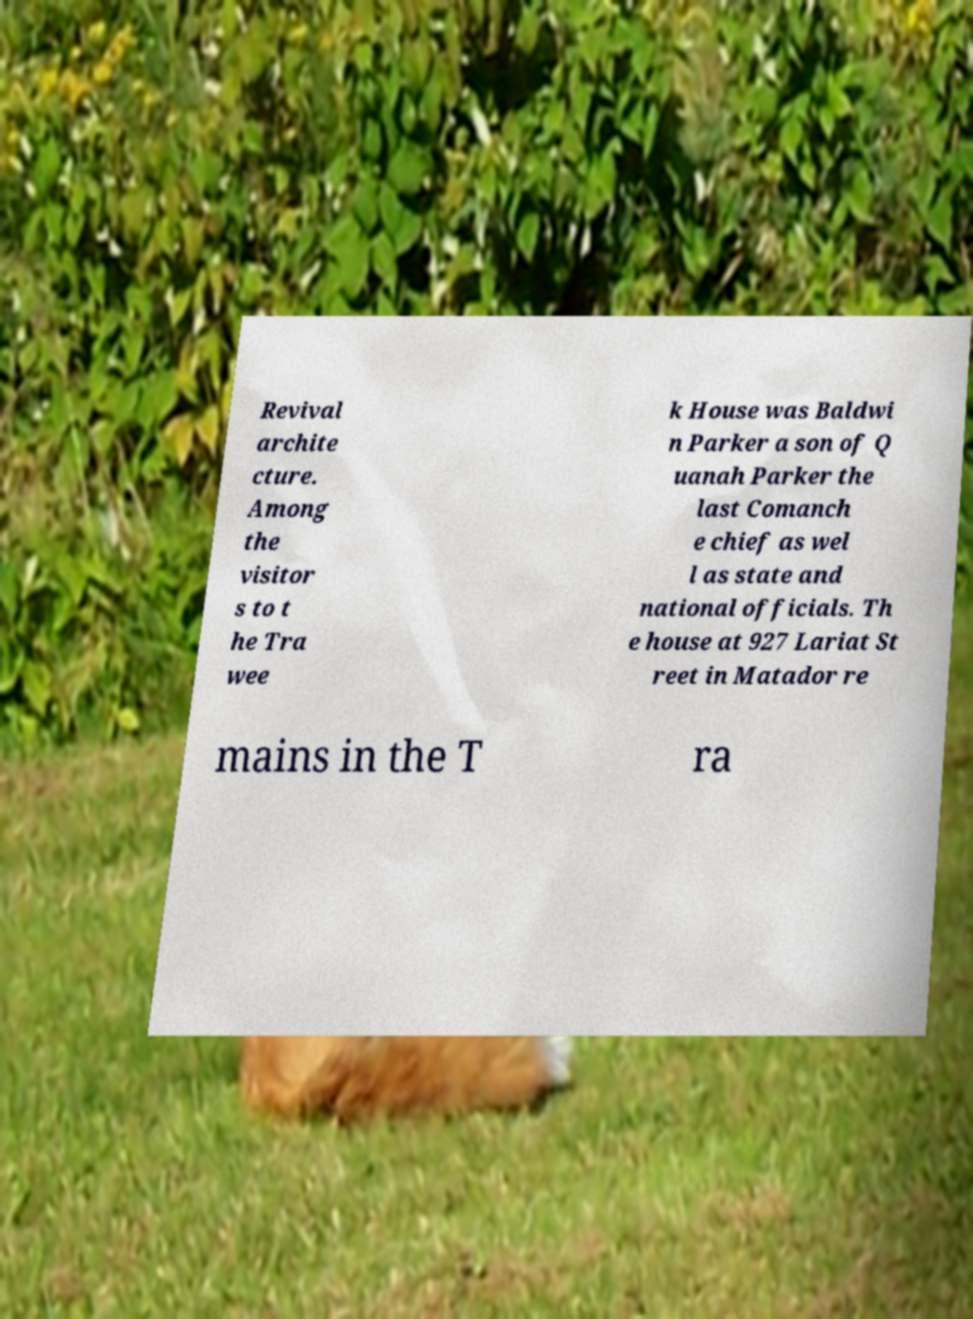For documentation purposes, I need the text within this image transcribed. Could you provide that? Revival archite cture. Among the visitor s to t he Tra wee k House was Baldwi n Parker a son of Q uanah Parker the last Comanch e chief as wel l as state and national officials. Th e house at 927 Lariat St reet in Matador re mains in the T ra 